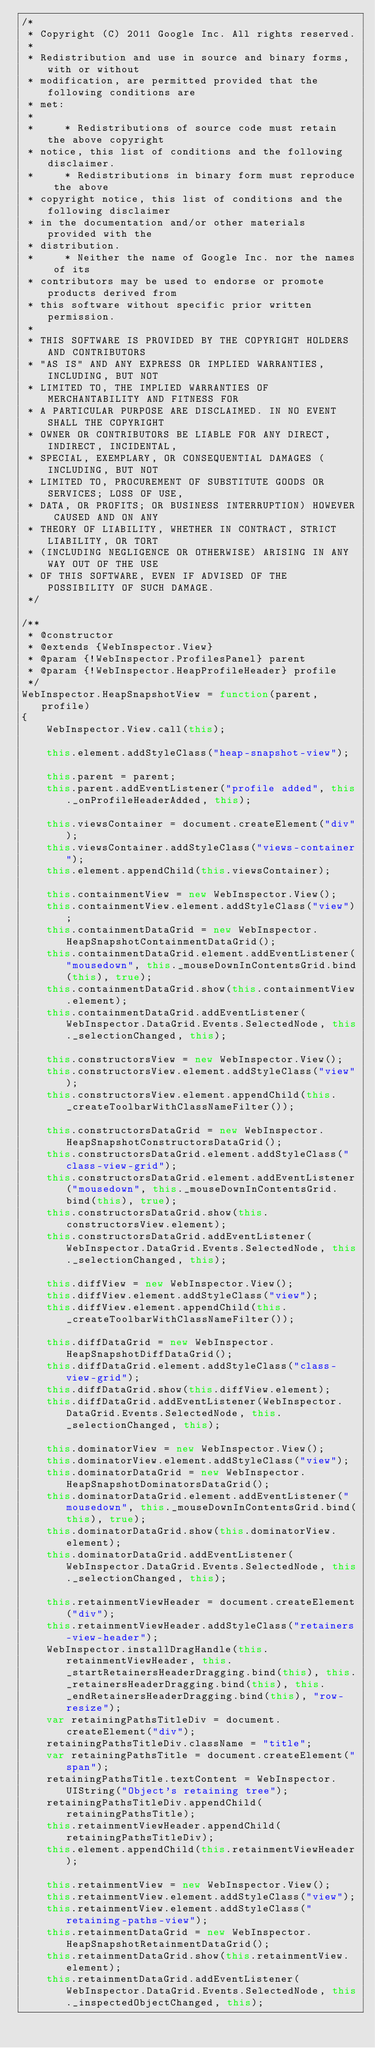<code> <loc_0><loc_0><loc_500><loc_500><_JavaScript_>/*
 * Copyright (C) 2011 Google Inc. All rights reserved.
 *
 * Redistribution and use in source and binary forms, with or without
 * modification, are permitted provided that the following conditions are
 * met:
 *
 *     * Redistributions of source code must retain the above copyright
 * notice, this list of conditions and the following disclaimer.
 *     * Redistributions in binary form must reproduce the above
 * copyright notice, this list of conditions and the following disclaimer
 * in the documentation and/or other materials provided with the
 * distribution.
 *     * Neither the name of Google Inc. nor the names of its
 * contributors may be used to endorse or promote products derived from
 * this software without specific prior written permission.
 *
 * THIS SOFTWARE IS PROVIDED BY THE COPYRIGHT HOLDERS AND CONTRIBUTORS
 * "AS IS" AND ANY EXPRESS OR IMPLIED WARRANTIES, INCLUDING, BUT NOT
 * LIMITED TO, THE IMPLIED WARRANTIES OF MERCHANTABILITY AND FITNESS FOR
 * A PARTICULAR PURPOSE ARE DISCLAIMED. IN NO EVENT SHALL THE COPYRIGHT
 * OWNER OR CONTRIBUTORS BE LIABLE FOR ANY DIRECT, INDIRECT, INCIDENTAL,
 * SPECIAL, EXEMPLARY, OR CONSEQUENTIAL DAMAGES (INCLUDING, BUT NOT
 * LIMITED TO, PROCUREMENT OF SUBSTITUTE GOODS OR SERVICES; LOSS OF USE,
 * DATA, OR PROFITS; OR BUSINESS INTERRUPTION) HOWEVER CAUSED AND ON ANY
 * THEORY OF LIABILITY, WHETHER IN CONTRACT, STRICT LIABILITY, OR TORT
 * (INCLUDING NEGLIGENCE OR OTHERWISE) ARISING IN ANY WAY OUT OF THE USE
 * OF THIS SOFTWARE, EVEN IF ADVISED OF THE POSSIBILITY OF SUCH DAMAGE.
 */

/**
 * @constructor
 * @extends {WebInspector.View}
 * @param {!WebInspector.ProfilesPanel} parent
 * @param {!WebInspector.HeapProfileHeader} profile
 */
WebInspector.HeapSnapshotView = function(parent, profile)
{
    WebInspector.View.call(this);

    this.element.addStyleClass("heap-snapshot-view");

    this.parent = parent;
    this.parent.addEventListener("profile added", this._onProfileHeaderAdded, this);

    this.viewsContainer = document.createElement("div");
    this.viewsContainer.addStyleClass("views-container");
    this.element.appendChild(this.viewsContainer);

    this.containmentView = new WebInspector.View();
    this.containmentView.element.addStyleClass("view");
    this.containmentDataGrid = new WebInspector.HeapSnapshotContainmentDataGrid();
    this.containmentDataGrid.element.addEventListener("mousedown", this._mouseDownInContentsGrid.bind(this), true);
    this.containmentDataGrid.show(this.containmentView.element);
    this.containmentDataGrid.addEventListener(WebInspector.DataGrid.Events.SelectedNode, this._selectionChanged, this);

    this.constructorsView = new WebInspector.View();
    this.constructorsView.element.addStyleClass("view");
    this.constructorsView.element.appendChild(this._createToolbarWithClassNameFilter());

    this.constructorsDataGrid = new WebInspector.HeapSnapshotConstructorsDataGrid();
    this.constructorsDataGrid.element.addStyleClass("class-view-grid");
    this.constructorsDataGrid.element.addEventListener("mousedown", this._mouseDownInContentsGrid.bind(this), true);
    this.constructorsDataGrid.show(this.constructorsView.element);
    this.constructorsDataGrid.addEventListener(WebInspector.DataGrid.Events.SelectedNode, this._selectionChanged, this);

    this.diffView = new WebInspector.View();
    this.diffView.element.addStyleClass("view");
    this.diffView.element.appendChild(this._createToolbarWithClassNameFilter());

    this.diffDataGrid = new WebInspector.HeapSnapshotDiffDataGrid();
    this.diffDataGrid.element.addStyleClass("class-view-grid");
    this.diffDataGrid.show(this.diffView.element);
    this.diffDataGrid.addEventListener(WebInspector.DataGrid.Events.SelectedNode, this._selectionChanged, this);

    this.dominatorView = new WebInspector.View();
    this.dominatorView.element.addStyleClass("view");
    this.dominatorDataGrid = new WebInspector.HeapSnapshotDominatorsDataGrid();
    this.dominatorDataGrid.element.addEventListener("mousedown", this._mouseDownInContentsGrid.bind(this), true);
    this.dominatorDataGrid.show(this.dominatorView.element);
    this.dominatorDataGrid.addEventListener(WebInspector.DataGrid.Events.SelectedNode, this._selectionChanged, this);

    this.retainmentViewHeader = document.createElement("div");
    this.retainmentViewHeader.addStyleClass("retainers-view-header");
    WebInspector.installDragHandle(this.retainmentViewHeader, this._startRetainersHeaderDragging.bind(this), this._retainersHeaderDragging.bind(this), this._endRetainersHeaderDragging.bind(this), "row-resize");
    var retainingPathsTitleDiv = document.createElement("div");
    retainingPathsTitleDiv.className = "title";
    var retainingPathsTitle = document.createElement("span");
    retainingPathsTitle.textContent = WebInspector.UIString("Object's retaining tree");
    retainingPathsTitleDiv.appendChild(retainingPathsTitle);
    this.retainmentViewHeader.appendChild(retainingPathsTitleDiv);
    this.element.appendChild(this.retainmentViewHeader);

    this.retainmentView = new WebInspector.View();
    this.retainmentView.element.addStyleClass("view");
    this.retainmentView.element.addStyleClass("retaining-paths-view");
    this.retainmentDataGrid = new WebInspector.HeapSnapshotRetainmentDataGrid();
    this.retainmentDataGrid.show(this.retainmentView.element);
    this.retainmentDataGrid.addEventListener(WebInspector.DataGrid.Events.SelectedNode, this._inspectedObjectChanged, this);</code> 